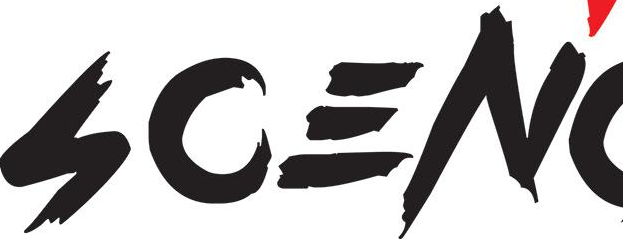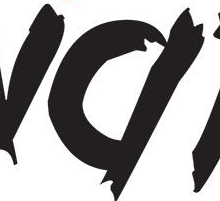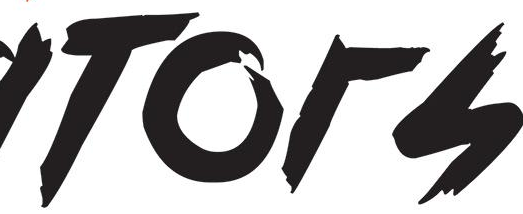What words are shown in these images in order, separated by a semicolon? SCEN; #; TOrS 